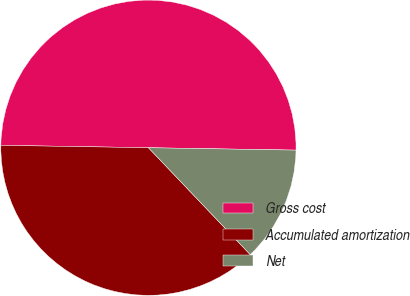Convert chart to OTSL. <chart><loc_0><loc_0><loc_500><loc_500><pie_chart><fcel>Gross cost<fcel>Accumulated amortization<fcel>Net<nl><fcel>50.0%<fcel>37.37%<fcel>12.63%<nl></chart> 